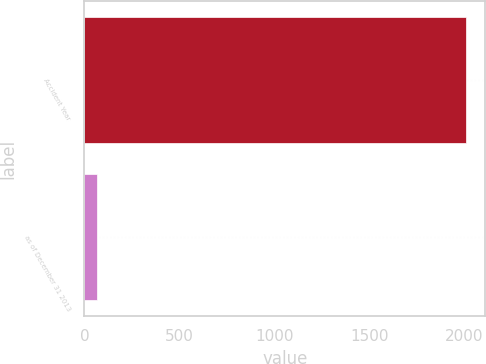<chart> <loc_0><loc_0><loc_500><loc_500><bar_chart><fcel>Accident Year<fcel>as of December 31 2013<nl><fcel>2011<fcel>67<nl></chart> 